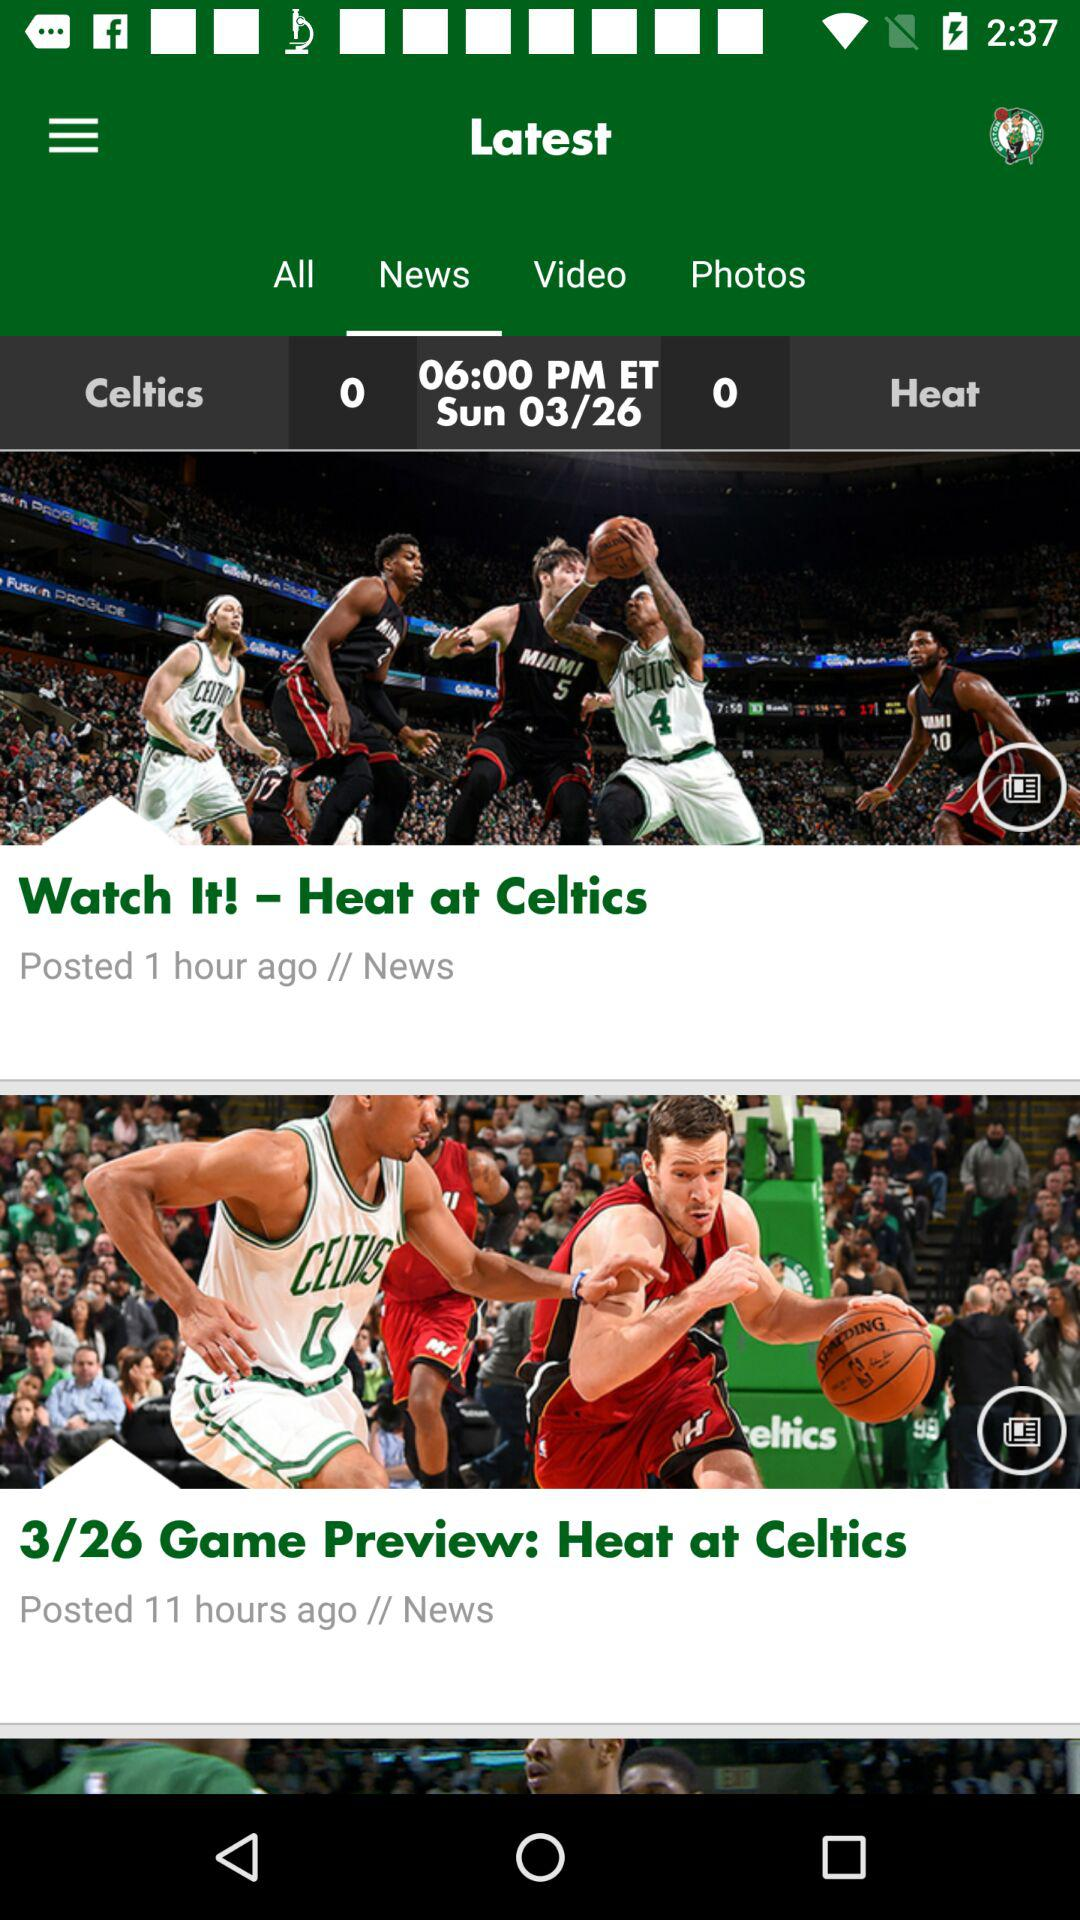What is the time of the news? The time is 06:00 PM. 